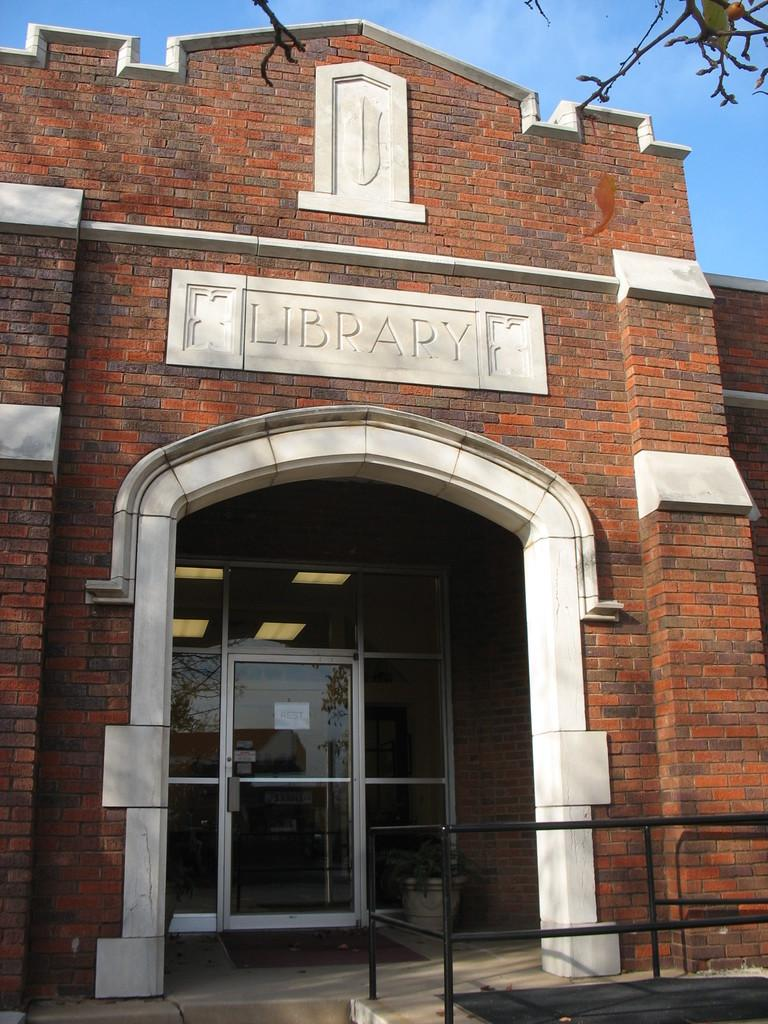<image>
Present a compact description of the photo's key features. A brick and white stone building's door which has a sign reading Library 